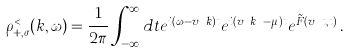<formula> <loc_0><loc_0><loc_500><loc_500>\rho _ { + , \sigma } ^ { < } ( k , \omega ) = \frac { 1 } { 2 \pi } \int _ { - \infty } ^ { \infty } d t e ^ { i ( \omega - v _ { F } k ) t } e ^ { i ( v _ { F } k _ { F } - \mu ) t } e ^ { \tilde { F } ( v _ { F } t , t ) } \, .</formula> 